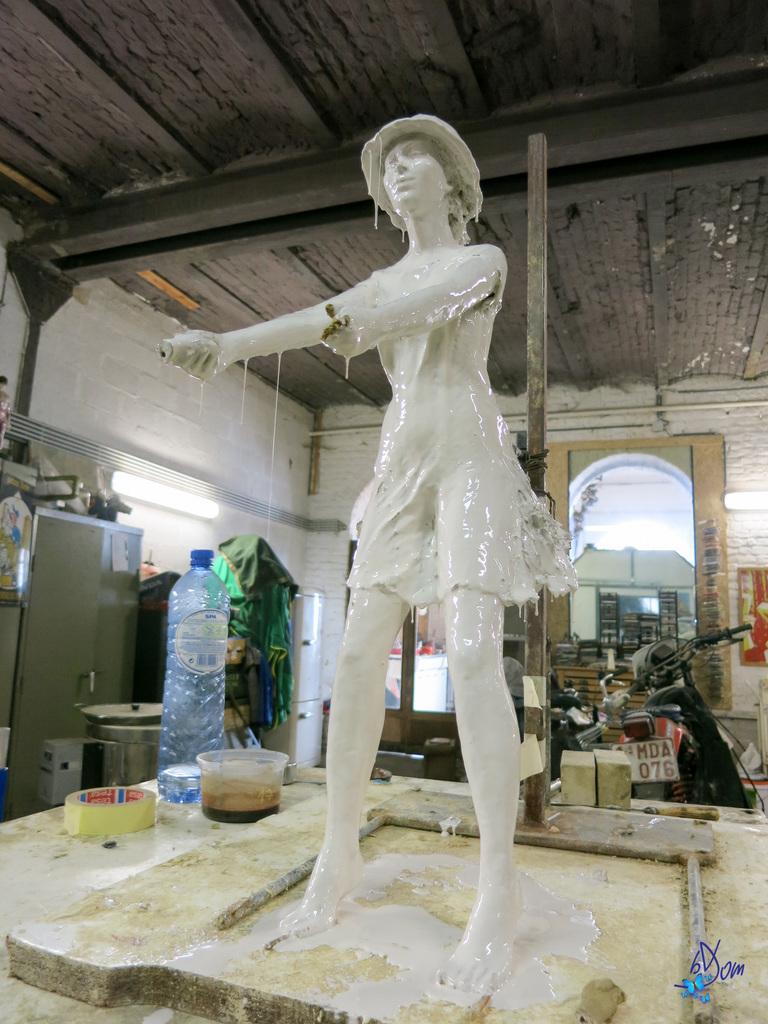How would you summarize this image in a sentence or two? In this image I see a sculpture and beside to it there is a bottle, a bowl and other thing. In the background I see the wall, a bike, few things over here and lights. 